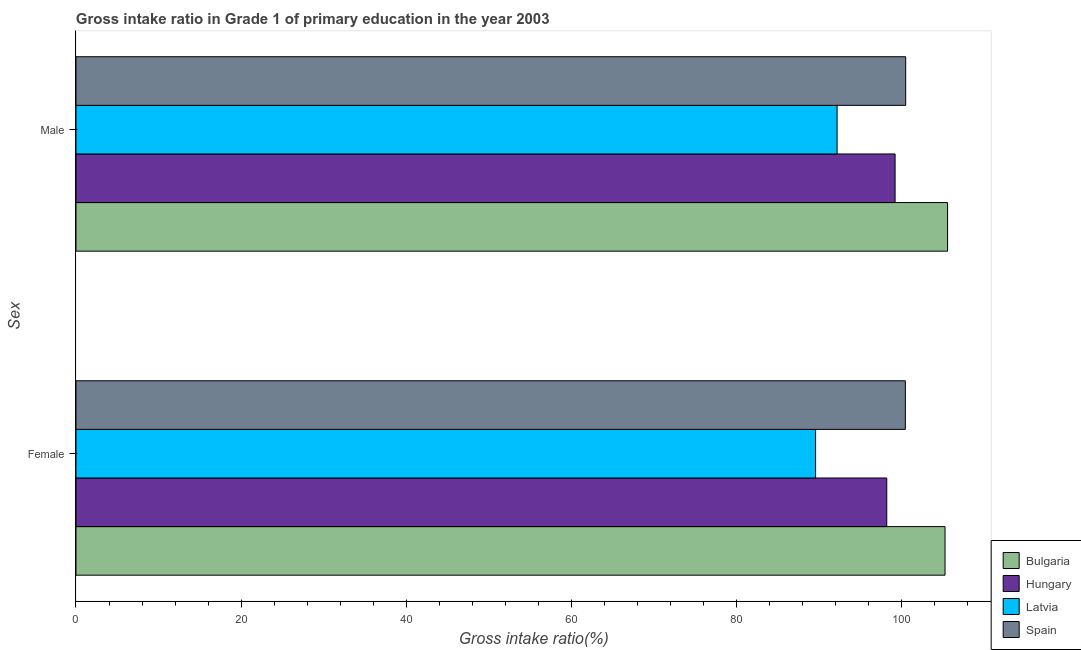How many different coloured bars are there?
Offer a very short reply. 4. How many groups of bars are there?
Give a very brief answer. 2. Are the number of bars per tick equal to the number of legend labels?
Your response must be concise. Yes. Are the number of bars on each tick of the Y-axis equal?
Your response must be concise. Yes. How many bars are there on the 1st tick from the top?
Offer a terse response. 4. How many bars are there on the 1st tick from the bottom?
Your answer should be very brief. 4. What is the label of the 1st group of bars from the top?
Keep it short and to the point. Male. What is the gross intake ratio(female) in Spain?
Your answer should be very brief. 100.43. Across all countries, what is the maximum gross intake ratio(female)?
Give a very brief answer. 105.24. Across all countries, what is the minimum gross intake ratio(female)?
Your answer should be very brief. 89.56. In which country was the gross intake ratio(male) maximum?
Ensure brevity in your answer.  Bulgaria. In which country was the gross intake ratio(male) minimum?
Provide a succinct answer. Latvia. What is the total gross intake ratio(male) in the graph?
Your answer should be compact. 397.37. What is the difference between the gross intake ratio(female) in Spain and that in Bulgaria?
Ensure brevity in your answer.  -4.81. What is the difference between the gross intake ratio(male) in Bulgaria and the gross intake ratio(female) in Spain?
Provide a short and direct response. 5.11. What is the average gross intake ratio(female) per country?
Keep it short and to the point. 98.35. What is the difference between the gross intake ratio(female) and gross intake ratio(male) in Spain?
Give a very brief answer. -0.04. In how many countries, is the gross intake ratio(female) greater than 12 %?
Ensure brevity in your answer.  4. What is the ratio of the gross intake ratio(female) in Latvia to that in Spain?
Offer a terse response. 0.89. In how many countries, is the gross intake ratio(male) greater than the average gross intake ratio(male) taken over all countries?
Give a very brief answer. 2. What does the 1st bar from the top in Female represents?
Ensure brevity in your answer.  Spain. What does the 3rd bar from the bottom in Female represents?
Your answer should be compact. Latvia. How many bars are there?
Provide a short and direct response. 8. Are all the bars in the graph horizontal?
Provide a succinct answer. Yes. What is the difference between two consecutive major ticks on the X-axis?
Provide a short and direct response. 20. How are the legend labels stacked?
Your answer should be very brief. Vertical. What is the title of the graph?
Ensure brevity in your answer.  Gross intake ratio in Grade 1 of primary education in the year 2003. Does "Colombia" appear as one of the legend labels in the graph?
Ensure brevity in your answer.  No. What is the label or title of the X-axis?
Give a very brief answer. Gross intake ratio(%). What is the label or title of the Y-axis?
Your response must be concise. Sex. What is the Gross intake ratio(%) of Bulgaria in Female?
Ensure brevity in your answer.  105.24. What is the Gross intake ratio(%) in Hungary in Female?
Make the answer very short. 98.18. What is the Gross intake ratio(%) of Latvia in Female?
Ensure brevity in your answer.  89.56. What is the Gross intake ratio(%) in Spain in Female?
Your answer should be very brief. 100.43. What is the Gross intake ratio(%) in Bulgaria in Male?
Provide a succinct answer. 105.54. What is the Gross intake ratio(%) in Hungary in Male?
Offer a very short reply. 99.19. What is the Gross intake ratio(%) of Latvia in Male?
Make the answer very short. 92.16. What is the Gross intake ratio(%) in Spain in Male?
Ensure brevity in your answer.  100.47. Across all Sex, what is the maximum Gross intake ratio(%) of Bulgaria?
Offer a terse response. 105.54. Across all Sex, what is the maximum Gross intake ratio(%) of Hungary?
Your answer should be very brief. 99.19. Across all Sex, what is the maximum Gross intake ratio(%) of Latvia?
Provide a succinct answer. 92.16. Across all Sex, what is the maximum Gross intake ratio(%) of Spain?
Provide a succinct answer. 100.47. Across all Sex, what is the minimum Gross intake ratio(%) in Bulgaria?
Your answer should be compact. 105.24. Across all Sex, what is the minimum Gross intake ratio(%) in Hungary?
Give a very brief answer. 98.18. Across all Sex, what is the minimum Gross intake ratio(%) in Latvia?
Offer a terse response. 89.56. Across all Sex, what is the minimum Gross intake ratio(%) in Spain?
Make the answer very short. 100.43. What is the total Gross intake ratio(%) of Bulgaria in the graph?
Give a very brief answer. 210.78. What is the total Gross intake ratio(%) of Hungary in the graph?
Offer a very short reply. 197.37. What is the total Gross intake ratio(%) of Latvia in the graph?
Keep it short and to the point. 181.73. What is the total Gross intake ratio(%) of Spain in the graph?
Keep it short and to the point. 200.9. What is the difference between the Gross intake ratio(%) in Bulgaria in Female and that in Male?
Ensure brevity in your answer.  -0.31. What is the difference between the Gross intake ratio(%) of Hungary in Female and that in Male?
Offer a terse response. -1.01. What is the difference between the Gross intake ratio(%) of Latvia in Female and that in Male?
Your answer should be very brief. -2.6. What is the difference between the Gross intake ratio(%) of Spain in Female and that in Male?
Provide a short and direct response. -0.04. What is the difference between the Gross intake ratio(%) in Bulgaria in Female and the Gross intake ratio(%) in Hungary in Male?
Your answer should be compact. 6.05. What is the difference between the Gross intake ratio(%) in Bulgaria in Female and the Gross intake ratio(%) in Latvia in Male?
Provide a short and direct response. 13.07. What is the difference between the Gross intake ratio(%) in Bulgaria in Female and the Gross intake ratio(%) in Spain in Male?
Ensure brevity in your answer.  4.77. What is the difference between the Gross intake ratio(%) in Hungary in Female and the Gross intake ratio(%) in Latvia in Male?
Provide a succinct answer. 6.01. What is the difference between the Gross intake ratio(%) in Hungary in Female and the Gross intake ratio(%) in Spain in Male?
Give a very brief answer. -2.29. What is the difference between the Gross intake ratio(%) of Latvia in Female and the Gross intake ratio(%) of Spain in Male?
Your answer should be very brief. -10.91. What is the average Gross intake ratio(%) in Bulgaria per Sex?
Make the answer very short. 105.39. What is the average Gross intake ratio(%) of Hungary per Sex?
Ensure brevity in your answer.  98.68. What is the average Gross intake ratio(%) of Latvia per Sex?
Your answer should be very brief. 90.86. What is the average Gross intake ratio(%) of Spain per Sex?
Your answer should be compact. 100.45. What is the difference between the Gross intake ratio(%) in Bulgaria and Gross intake ratio(%) in Hungary in Female?
Provide a succinct answer. 7.06. What is the difference between the Gross intake ratio(%) of Bulgaria and Gross intake ratio(%) of Latvia in Female?
Keep it short and to the point. 15.68. What is the difference between the Gross intake ratio(%) in Bulgaria and Gross intake ratio(%) in Spain in Female?
Provide a short and direct response. 4.81. What is the difference between the Gross intake ratio(%) in Hungary and Gross intake ratio(%) in Latvia in Female?
Make the answer very short. 8.62. What is the difference between the Gross intake ratio(%) of Hungary and Gross intake ratio(%) of Spain in Female?
Keep it short and to the point. -2.25. What is the difference between the Gross intake ratio(%) of Latvia and Gross intake ratio(%) of Spain in Female?
Your answer should be compact. -10.87. What is the difference between the Gross intake ratio(%) in Bulgaria and Gross intake ratio(%) in Hungary in Male?
Your answer should be compact. 6.36. What is the difference between the Gross intake ratio(%) of Bulgaria and Gross intake ratio(%) of Latvia in Male?
Give a very brief answer. 13.38. What is the difference between the Gross intake ratio(%) in Bulgaria and Gross intake ratio(%) in Spain in Male?
Provide a succinct answer. 5.07. What is the difference between the Gross intake ratio(%) in Hungary and Gross intake ratio(%) in Latvia in Male?
Keep it short and to the point. 7.02. What is the difference between the Gross intake ratio(%) of Hungary and Gross intake ratio(%) of Spain in Male?
Your response must be concise. -1.28. What is the difference between the Gross intake ratio(%) of Latvia and Gross intake ratio(%) of Spain in Male?
Provide a short and direct response. -8.31. What is the ratio of the Gross intake ratio(%) of Bulgaria in Female to that in Male?
Offer a very short reply. 1. What is the ratio of the Gross intake ratio(%) of Hungary in Female to that in Male?
Keep it short and to the point. 0.99. What is the ratio of the Gross intake ratio(%) of Latvia in Female to that in Male?
Your answer should be compact. 0.97. What is the ratio of the Gross intake ratio(%) of Spain in Female to that in Male?
Your answer should be very brief. 1. What is the difference between the highest and the second highest Gross intake ratio(%) of Bulgaria?
Your response must be concise. 0.31. What is the difference between the highest and the second highest Gross intake ratio(%) of Hungary?
Make the answer very short. 1.01. What is the difference between the highest and the second highest Gross intake ratio(%) of Latvia?
Provide a short and direct response. 2.6. What is the difference between the highest and the second highest Gross intake ratio(%) of Spain?
Make the answer very short. 0.04. What is the difference between the highest and the lowest Gross intake ratio(%) in Bulgaria?
Keep it short and to the point. 0.31. What is the difference between the highest and the lowest Gross intake ratio(%) in Hungary?
Your answer should be very brief. 1.01. What is the difference between the highest and the lowest Gross intake ratio(%) of Latvia?
Offer a terse response. 2.6. What is the difference between the highest and the lowest Gross intake ratio(%) in Spain?
Offer a very short reply. 0.04. 